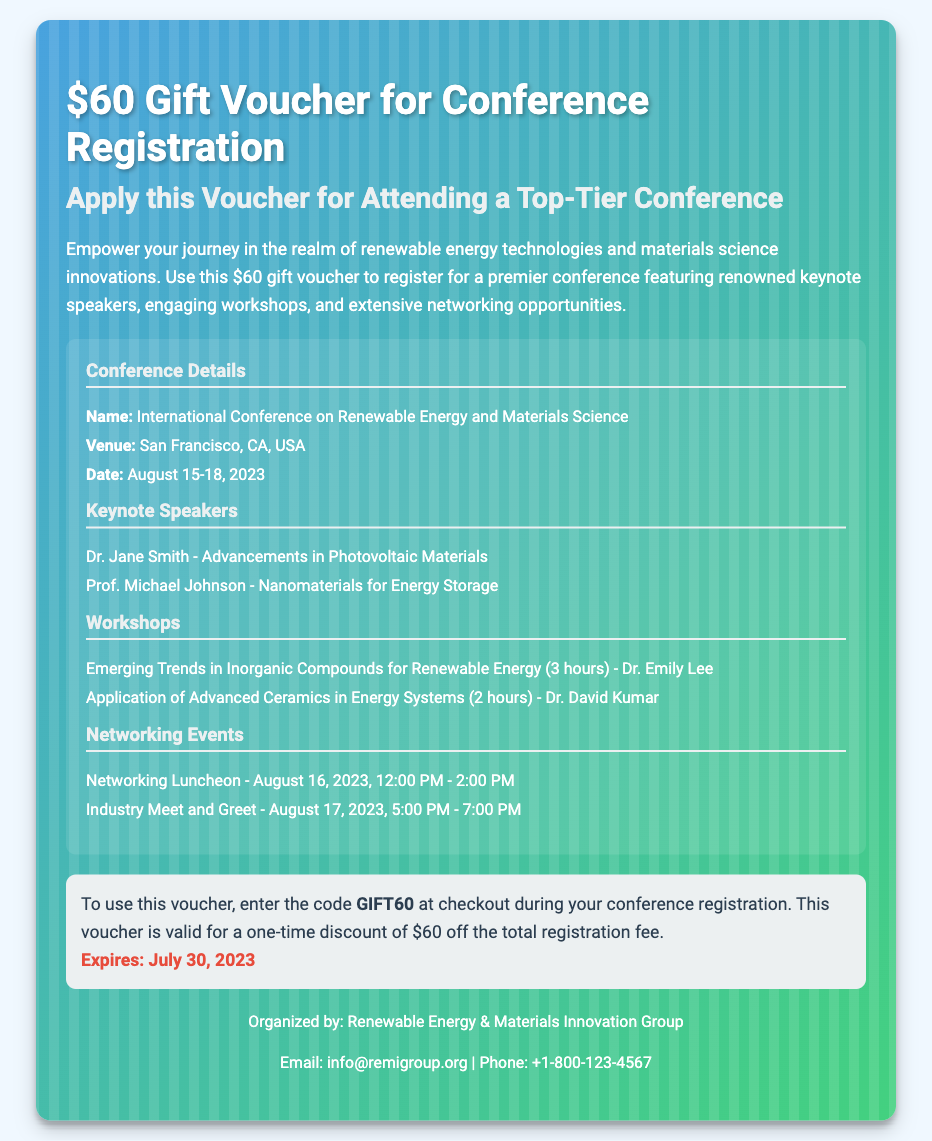what is the value of the gift voucher? The document states the voucher is worth $60 for conference registration.
Answer: $60 where is the conference taking place? The venue of the conference, as noted in the document, is San Francisco, CA, USA.
Answer: San Francisco, CA, USA what are the dates of the conference? The document specifies the conference dates as August 15-18, 2023.
Answer: August 15-18, 2023 who is one of the keynote speakers? The document lists Dr. Jane Smith as one of the keynote speakers.
Answer: Dr. Jane Smith how much is the discount provided by the voucher? The voucher provides a discount of $60 off the total registration fee.
Answer: $60 what workshop is given by Dr. Emily Lee? The document mentions the workshop "Emerging Trends in Inorganic Compounds for Renewable Energy" given by Dr. Emily Lee.
Answer: Emerging Trends in Inorganic Compounds for Renewable Energy when does the Networking Luncheon take place? According to the document, the Networking Luncheon is on August 16, 2023, from 12:00 PM to 2:00 PM.
Answer: August 16, 2023, 12:00 PM - 2:00 PM how do you use the voucher? The document states the code to use is GIFT60 during checkout for the conference registration.
Answer: GIFT60 when does the voucher expire? The expiry date of the voucher is mentioned in the document as July 30, 2023.
Answer: July 30, 2023 